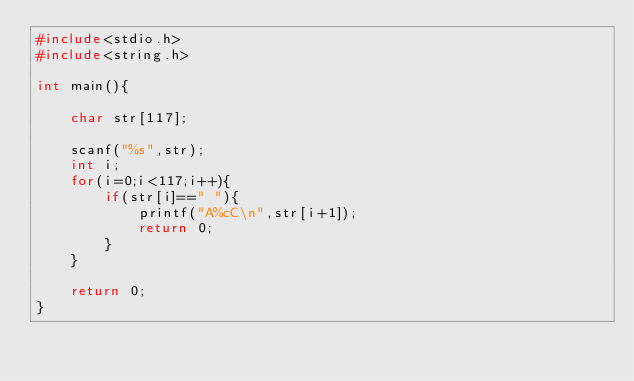Convert code to text. <code><loc_0><loc_0><loc_500><loc_500><_C_>#include<stdio.h>
#include<string.h>

int main(){

    char str[117];

    scanf("%s",str);
    int i;
    for(i=0;i<117;i++){
        if(str[i]==" "){
            printf("A%cC\n",str[i+1]);
            return 0;
        }
    }

    return 0;
}
</code> 